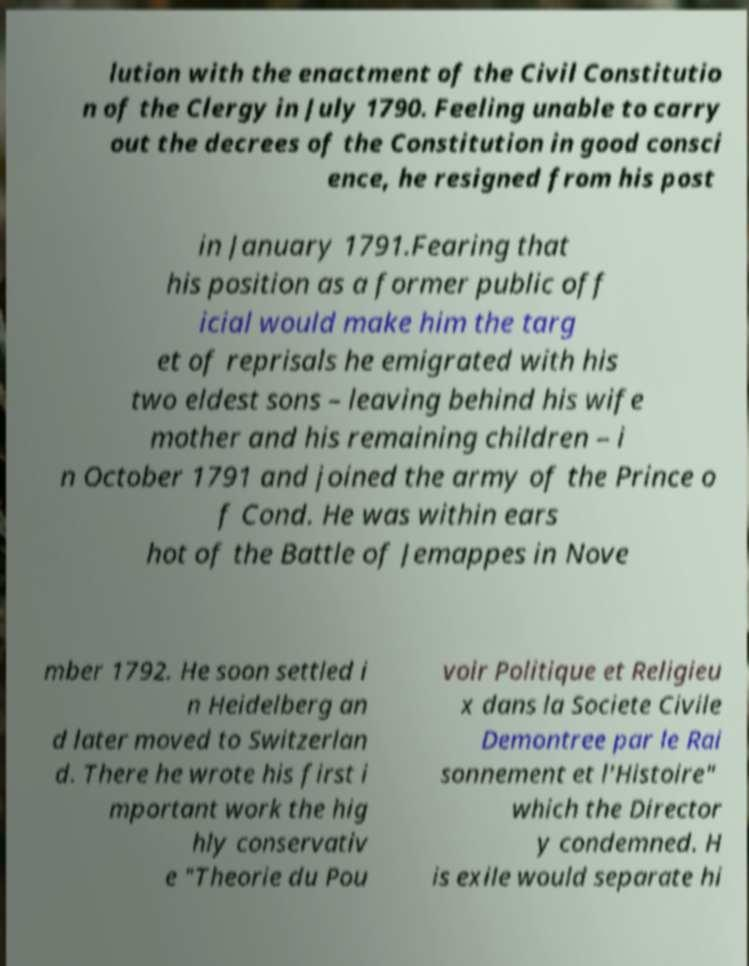Please identify and transcribe the text found in this image. lution with the enactment of the Civil Constitutio n of the Clergy in July 1790. Feeling unable to carry out the decrees of the Constitution in good consci ence, he resigned from his post in January 1791.Fearing that his position as a former public off icial would make him the targ et of reprisals he emigrated with his two eldest sons – leaving behind his wife mother and his remaining children – i n October 1791 and joined the army of the Prince o f Cond. He was within ears hot of the Battle of Jemappes in Nove mber 1792. He soon settled i n Heidelberg an d later moved to Switzerlan d. There he wrote his first i mportant work the hig hly conservativ e "Theorie du Pou voir Politique et Religieu x dans la Societe Civile Demontree par le Rai sonnement et l'Histoire" which the Director y condemned. H is exile would separate hi 